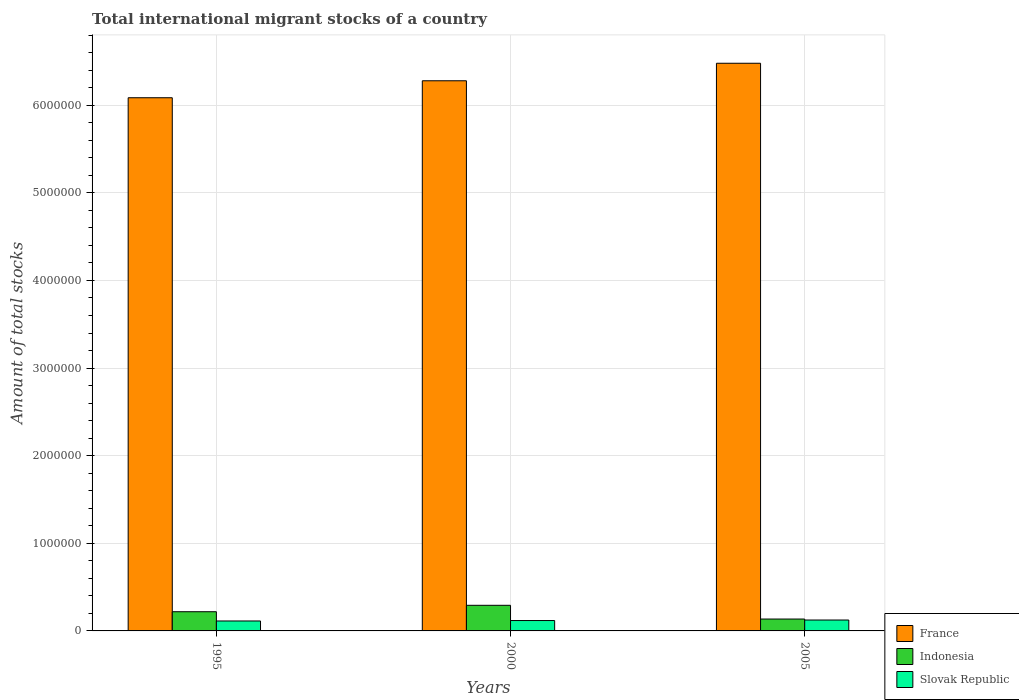How many groups of bars are there?
Give a very brief answer. 3. Are the number of bars on each tick of the X-axis equal?
Make the answer very short. Yes. How many bars are there on the 3rd tick from the right?
Provide a short and direct response. 3. What is the label of the 1st group of bars from the left?
Provide a succinct answer. 1995. What is the amount of total stocks in in France in 1995?
Your answer should be compact. 6.09e+06. Across all years, what is the maximum amount of total stocks in in Indonesia?
Your answer should be very brief. 2.92e+05. Across all years, what is the minimum amount of total stocks in in France?
Give a very brief answer. 6.09e+06. In which year was the amount of total stocks in in Slovak Republic minimum?
Keep it short and to the point. 1995. What is the total amount of total stocks in in France in the graph?
Your answer should be compact. 1.88e+07. What is the difference between the amount of total stocks in in France in 2000 and that in 2005?
Your response must be concise. -2.00e+05. What is the difference between the amount of total stocks in in Indonesia in 2000 and the amount of total stocks in in Slovak Republic in 1995?
Give a very brief answer. 1.79e+05. What is the average amount of total stocks in in Indonesia per year?
Make the answer very short. 2.16e+05. In the year 1995, what is the difference between the amount of total stocks in in Indonesia and amount of total stocks in in Slovak Republic?
Provide a short and direct response. 1.06e+05. In how many years, is the amount of total stocks in in Slovak Republic greater than 5800000?
Make the answer very short. 0. What is the ratio of the amount of total stocks in in Indonesia in 2000 to that in 2005?
Keep it short and to the point. 2.16. Is the amount of total stocks in in France in 1995 less than that in 2000?
Keep it short and to the point. Yes. What is the difference between the highest and the second highest amount of total stocks in in Indonesia?
Your response must be concise. 7.32e+04. What is the difference between the highest and the lowest amount of total stocks in in Indonesia?
Your answer should be compact. 1.57e+05. Is the sum of the amount of total stocks in in Slovak Republic in 1995 and 2000 greater than the maximum amount of total stocks in in Indonesia across all years?
Make the answer very short. No. What does the 2nd bar from the left in 2000 represents?
Ensure brevity in your answer.  Indonesia. Is it the case that in every year, the sum of the amount of total stocks in in Indonesia and amount of total stocks in in Slovak Republic is greater than the amount of total stocks in in France?
Give a very brief answer. No. How many years are there in the graph?
Your response must be concise. 3. Are the values on the major ticks of Y-axis written in scientific E-notation?
Keep it short and to the point. No. What is the title of the graph?
Your answer should be very brief. Total international migrant stocks of a country. Does "West Bank and Gaza" appear as one of the legend labels in the graph?
Keep it short and to the point. No. What is the label or title of the X-axis?
Give a very brief answer. Years. What is the label or title of the Y-axis?
Offer a terse response. Amount of total stocks. What is the Amount of total stocks in France in 1995?
Your answer should be compact. 6.09e+06. What is the Amount of total stocks in Indonesia in 1995?
Your response must be concise. 2.19e+05. What is the Amount of total stocks in Slovak Republic in 1995?
Give a very brief answer. 1.14e+05. What is the Amount of total stocks in France in 2000?
Your answer should be compact. 6.28e+06. What is the Amount of total stocks in Indonesia in 2000?
Offer a very short reply. 2.92e+05. What is the Amount of total stocks of Slovak Republic in 2000?
Your answer should be very brief. 1.18e+05. What is the Amount of total stocks of France in 2005?
Offer a terse response. 6.48e+06. What is the Amount of total stocks in Indonesia in 2005?
Your answer should be compact. 1.36e+05. What is the Amount of total stocks of Slovak Republic in 2005?
Your response must be concise. 1.24e+05. Across all years, what is the maximum Amount of total stocks in France?
Your answer should be compact. 6.48e+06. Across all years, what is the maximum Amount of total stocks of Indonesia?
Your answer should be compact. 2.92e+05. Across all years, what is the maximum Amount of total stocks of Slovak Republic?
Your answer should be very brief. 1.24e+05. Across all years, what is the minimum Amount of total stocks in France?
Provide a short and direct response. 6.09e+06. Across all years, what is the minimum Amount of total stocks in Indonesia?
Provide a short and direct response. 1.36e+05. Across all years, what is the minimum Amount of total stocks of Slovak Republic?
Your response must be concise. 1.14e+05. What is the total Amount of total stocks in France in the graph?
Your answer should be very brief. 1.88e+07. What is the total Amount of total stocks of Indonesia in the graph?
Provide a short and direct response. 6.47e+05. What is the total Amount of total stocks in Slovak Republic in the graph?
Provide a succinct answer. 3.56e+05. What is the difference between the Amount of total stocks in France in 1995 and that in 2000?
Your answer should be compact. -1.94e+05. What is the difference between the Amount of total stocks of Indonesia in 1995 and that in 2000?
Keep it short and to the point. -7.32e+04. What is the difference between the Amount of total stocks in Slovak Republic in 1995 and that in 2000?
Provide a succinct answer. -4957. What is the difference between the Amount of total stocks of France in 1995 and that in 2005?
Keep it short and to the point. -3.94e+05. What is the difference between the Amount of total stocks of Indonesia in 1995 and that in 2005?
Your answer should be very brief. 8.35e+04. What is the difference between the Amount of total stocks of Slovak Republic in 1995 and that in 2005?
Provide a succinct answer. -1.09e+04. What is the difference between the Amount of total stocks in France in 2000 and that in 2005?
Offer a very short reply. -2.00e+05. What is the difference between the Amount of total stocks in Indonesia in 2000 and that in 2005?
Provide a short and direct response. 1.57e+05. What is the difference between the Amount of total stocks in Slovak Republic in 2000 and that in 2005?
Give a very brief answer. -5989. What is the difference between the Amount of total stocks in France in 1995 and the Amount of total stocks in Indonesia in 2000?
Make the answer very short. 5.79e+06. What is the difference between the Amount of total stocks of France in 1995 and the Amount of total stocks of Slovak Republic in 2000?
Provide a short and direct response. 5.97e+06. What is the difference between the Amount of total stocks in Indonesia in 1995 and the Amount of total stocks in Slovak Republic in 2000?
Give a very brief answer. 1.01e+05. What is the difference between the Amount of total stocks in France in 1995 and the Amount of total stocks in Indonesia in 2005?
Ensure brevity in your answer.  5.95e+06. What is the difference between the Amount of total stocks in France in 1995 and the Amount of total stocks in Slovak Republic in 2005?
Offer a terse response. 5.96e+06. What is the difference between the Amount of total stocks of Indonesia in 1995 and the Amount of total stocks of Slovak Republic in 2005?
Ensure brevity in your answer.  9.47e+04. What is the difference between the Amount of total stocks in France in 2000 and the Amount of total stocks in Indonesia in 2005?
Ensure brevity in your answer.  6.14e+06. What is the difference between the Amount of total stocks of France in 2000 and the Amount of total stocks of Slovak Republic in 2005?
Offer a terse response. 6.15e+06. What is the difference between the Amount of total stocks in Indonesia in 2000 and the Amount of total stocks in Slovak Republic in 2005?
Provide a succinct answer. 1.68e+05. What is the average Amount of total stocks of France per year?
Offer a terse response. 6.28e+06. What is the average Amount of total stocks of Indonesia per year?
Your answer should be compact. 2.16e+05. What is the average Amount of total stocks in Slovak Republic per year?
Your answer should be very brief. 1.19e+05. In the year 1995, what is the difference between the Amount of total stocks in France and Amount of total stocks in Indonesia?
Your answer should be compact. 5.87e+06. In the year 1995, what is the difference between the Amount of total stocks of France and Amount of total stocks of Slovak Republic?
Provide a succinct answer. 5.97e+06. In the year 1995, what is the difference between the Amount of total stocks in Indonesia and Amount of total stocks in Slovak Republic?
Make the answer very short. 1.06e+05. In the year 2000, what is the difference between the Amount of total stocks of France and Amount of total stocks of Indonesia?
Provide a succinct answer. 5.99e+06. In the year 2000, what is the difference between the Amount of total stocks of France and Amount of total stocks of Slovak Republic?
Make the answer very short. 6.16e+06. In the year 2000, what is the difference between the Amount of total stocks of Indonesia and Amount of total stocks of Slovak Republic?
Offer a very short reply. 1.74e+05. In the year 2005, what is the difference between the Amount of total stocks in France and Amount of total stocks in Indonesia?
Ensure brevity in your answer.  6.34e+06. In the year 2005, what is the difference between the Amount of total stocks of France and Amount of total stocks of Slovak Republic?
Your response must be concise. 6.35e+06. In the year 2005, what is the difference between the Amount of total stocks in Indonesia and Amount of total stocks in Slovak Republic?
Give a very brief answer. 1.12e+04. What is the ratio of the Amount of total stocks of France in 1995 to that in 2000?
Your answer should be very brief. 0.97. What is the ratio of the Amount of total stocks of Indonesia in 1995 to that in 2000?
Your response must be concise. 0.75. What is the ratio of the Amount of total stocks in Slovak Republic in 1995 to that in 2000?
Your answer should be very brief. 0.96. What is the ratio of the Amount of total stocks of France in 1995 to that in 2005?
Provide a short and direct response. 0.94. What is the ratio of the Amount of total stocks in Indonesia in 1995 to that in 2005?
Keep it short and to the point. 1.62. What is the ratio of the Amount of total stocks in Slovak Republic in 1995 to that in 2005?
Your response must be concise. 0.91. What is the ratio of the Amount of total stocks in France in 2000 to that in 2005?
Your answer should be compact. 0.97. What is the ratio of the Amount of total stocks of Indonesia in 2000 to that in 2005?
Keep it short and to the point. 2.16. What is the ratio of the Amount of total stocks in Slovak Republic in 2000 to that in 2005?
Give a very brief answer. 0.95. What is the difference between the highest and the second highest Amount of total stocks of France?
Keep it short and to the point. 2.00e+05. What is the difference between the highest and the second highest Amount of total stocks in Indonesia?
Your answer should be very brief. 7.32e+04. What is the difference between the highest and the second highest Amount of total stocks of Slovak Republic?
Your answer should be very brief. 5989. What is the difference between the highest and the lowest Amount of total stocks in France?
Your response must be concise. 3.94e+05. What is the difference between the highest and the lowest Amount of total stocks of Indonesia?
Your answer should be compact. 1.57e+05. What is the difference between the highest and the lowest Amount of total stocks in Slovak Republic?
Your answer should be very brief. 1.09e+04. 